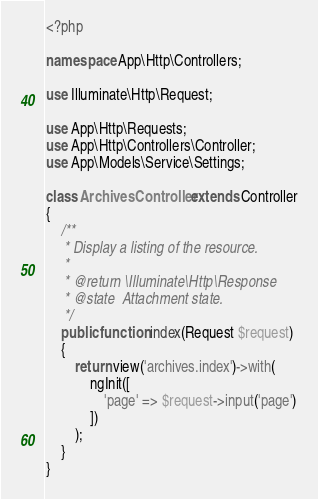<code> <loc_0><loc_0><loc_500><loc_500><_PHP_><?php

namespace App\Http\Controllers;

use Illuminate\Http\Request;

use App\Http\Requests;
use App\Http\Controllers\Controller;
use App\Models\Service\Settings;

class ArchivesController extends Controller
{
    /**
     * Display a listing of the resource.
     *
     * @return \Illuminate\Http\Response
     * @state  Attachment state.
     */
    public function index(Request $request)
    {
        return view('archives.index')->with(
            ngInit([
                'page' => $request->input('page')
            ])
        );
    }
}
</code> 